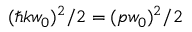<formula> <loc_0><loc_0><loc_500><loc_500>( \hbar { k } w _ { 0 } ) ^ { 2 } / 2 = ( p w _ { 0 } ) ^ { 2 } / 2</formula> 